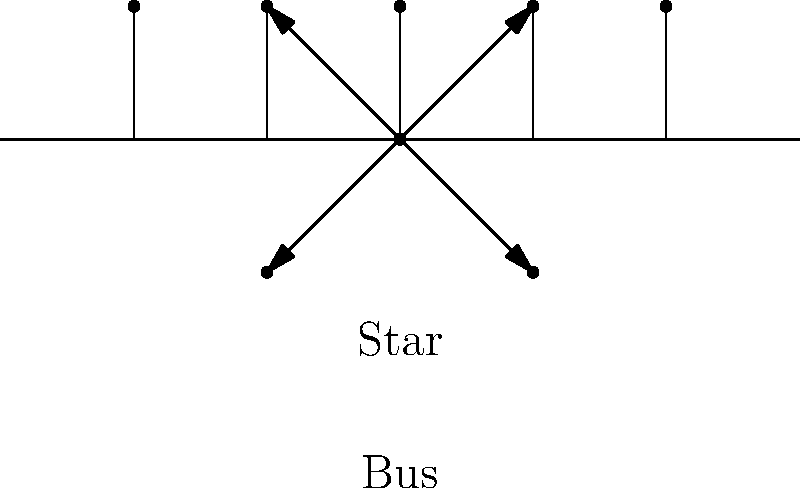As a busy parent setting up a home office in Saitama, you're considering different network topologies for your family's devices. Which topology would be more suitable for your home office: Star or Bus? Consider factors like ease of troubleshooting and the impact of device failures on the network. To determine the most suitable topology for a home office, let's compare the Star and Bus topologies:

1. Star Topology:
   - All devices connect directly to a central hub or switch
   - Easy to add or remove devices without disrupting the network
   - If one device fails, it doesn't affect others
   - Easier to troubleshoot as each connection is isolated
   - Requires more cabling, but cable length is typically shorter

2. Bus Topology:
   - All devices connect to a single cable
   - Cheaper to implement due to less cabling
   - If the main cable fails, the entire network goes down
   - Adding or removing devices can disrupt the network
   - Harder to troubleshoot as issues can affect the entire network

For a busy parent with small children in a home office setting:
- Ease of troubleshooting is crucial due to time constraints
- Network reliability is important for uninterrupted work
- Flexibility to add or remove devices without disrupting others is beneficial

The Star topology offers these advantages:
- Easier to isolate and fix issues without affecting the whole network
- More reliable as one device failure doesn't impact others
- Allows for easy addition of new devices (e.g., children's tablets, smart home devices)

While the Bus topology might be cheaper, the benefits of the Star topology outweigh the cost difference for a home office setting, especially considering the need for reliability and ease of management for a busy parent.
Answer: Star topology 